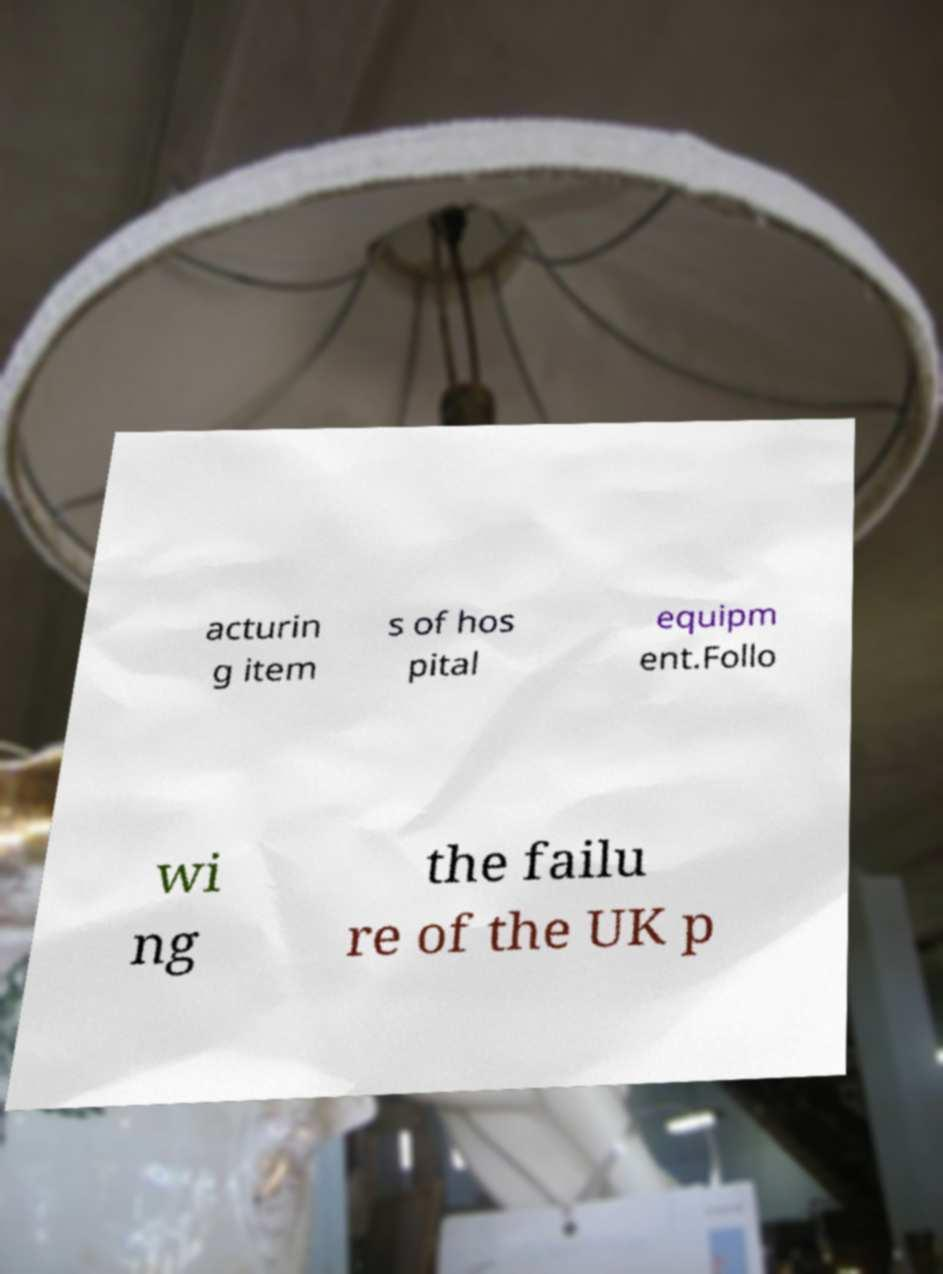Could you extract and type out the text from this image? acturin g item s of hos pital equipm ent.Follo wi ng the failu re of the UK p 